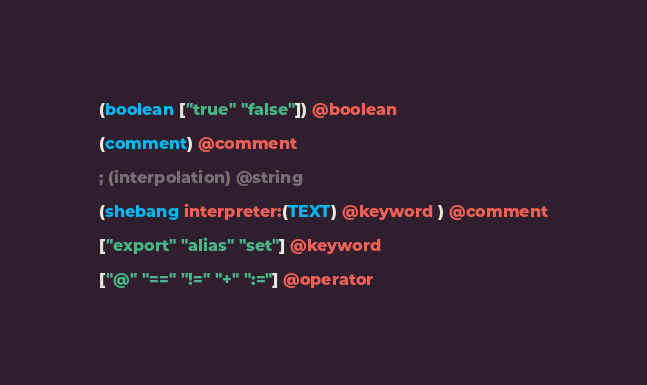<code> <loc_0><loc_0><loc_500><loc_500><_Scheme_>
(boolean ["true" "false"]) @boolean

(comment) @comment

; (interpolation) @string

(shebang interpreter:(TEXT) @keyword ) @comment

["export" "alias" "set"] @keyword

["@" "==" "!=" "+" ":="] @operator
</code> 